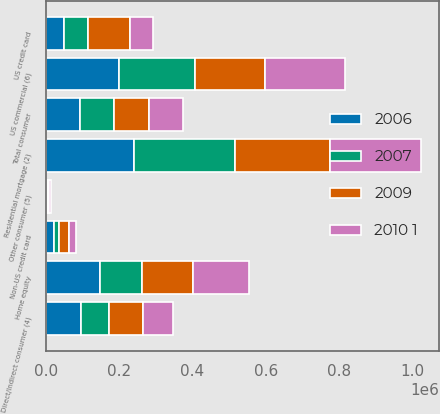Convert chart to OTSL. <chart><loc_0><loc_0><loc_500><loc_500><stacked_bar_chart><ecel><fcel>Residential mortgage (2)<fcel>Home equity<fcel>US credit card<fcel>Non-US credit card<fcel>Direct/Indirect consumer (4)<fcel>Other consumer (5)<fcel>Total consumer<fcel>US commercial (6)<nl><fcel>2009<fcel>257973<fcel>137981<fcel>113785<fcel>27465<fcel>90308<fcel>2830<fcel>93772<fcel>190305<nl><fcel>2006<fcel>242129<fcel>149126<fcel>49453<fcel>21656<fcel>97236<fcel>3110<fcel>93772<fcel>198903<nl><fcel>2010 1<fcel>248063<fcel>152483<fcel>64128<fcel>17146<fcel>83436<fcel>3442<fcel>93772<fcel>219233<nl><fcel>2007<fcel>274949<fcel>114820<fcel>65774<fcel>14950<fcel>76538<fcel>4170<fcel>93772<fcel>208297<nl></chart> 